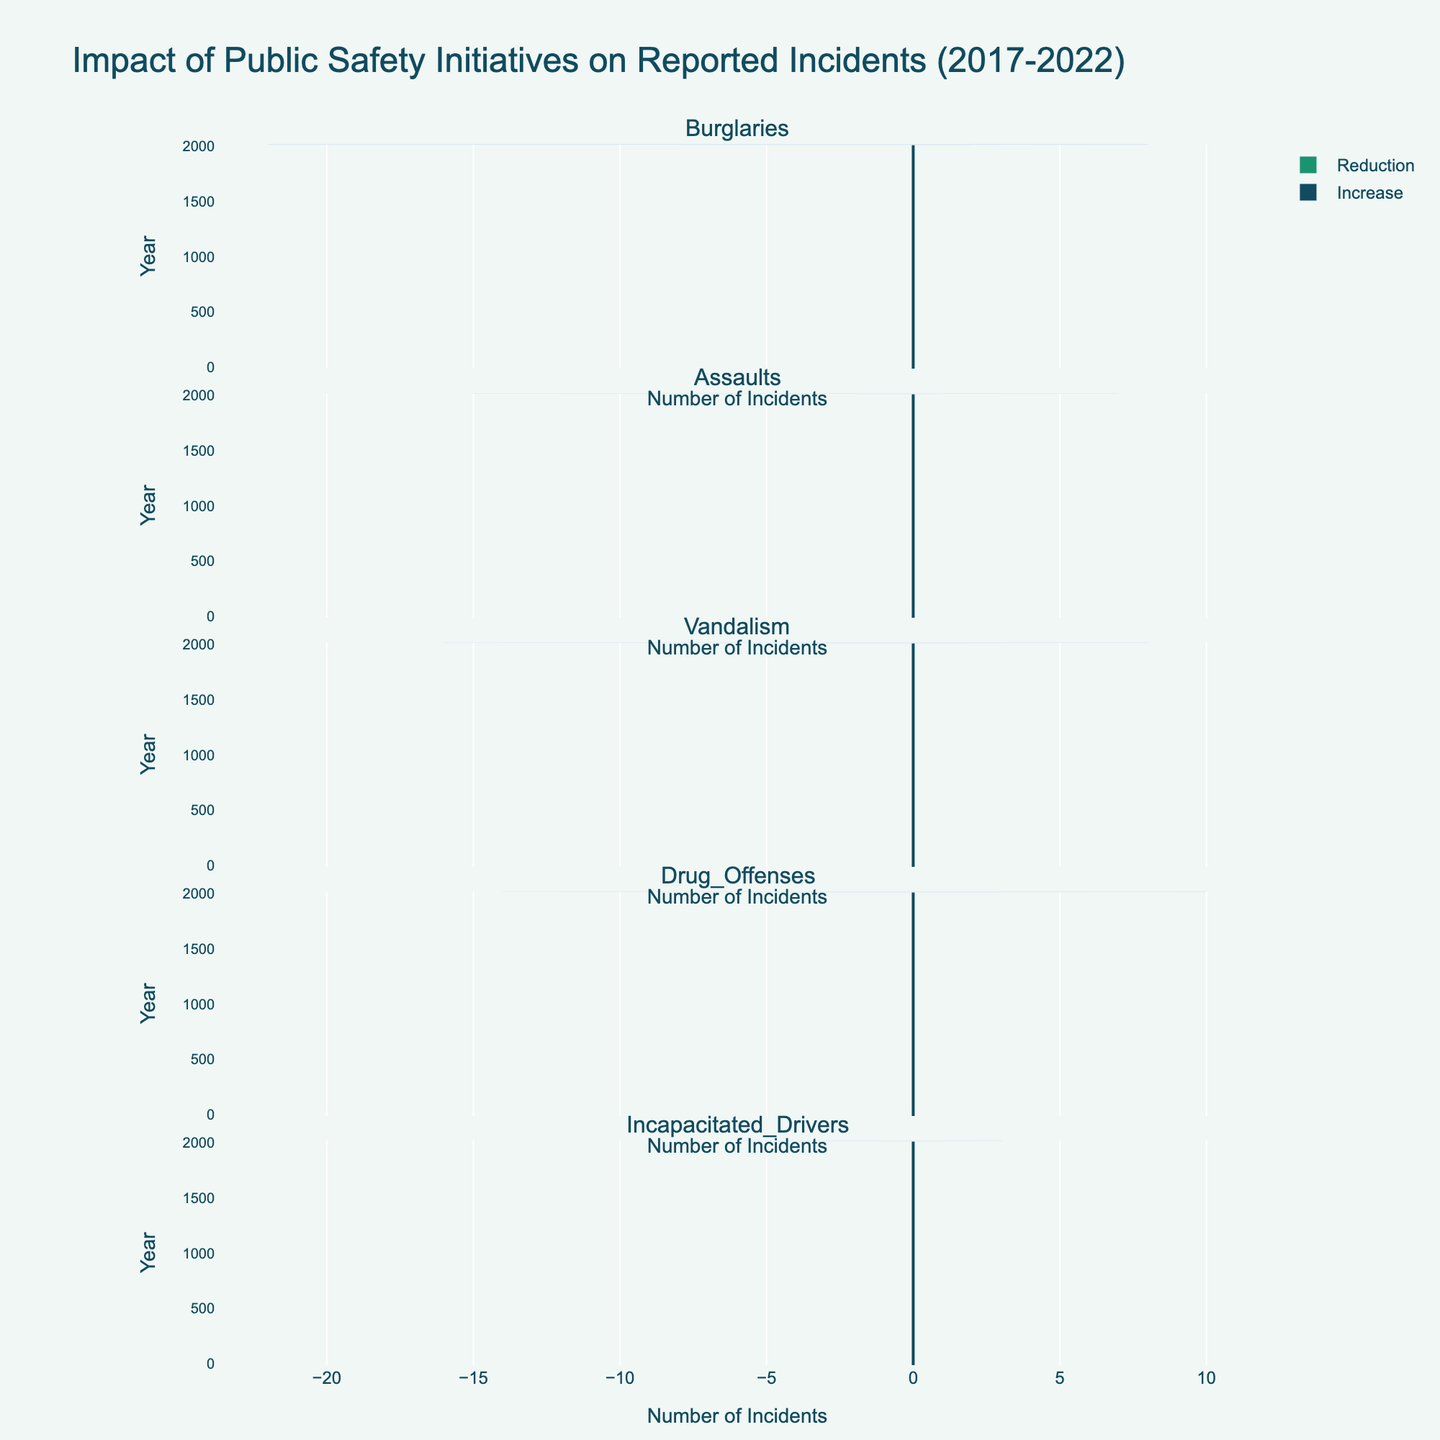What is the total increase in reported burglaries over the years 2017 to 2022? To find the total increase in burglaries, sum the increase values for burglaries from 2017 to 2022: 2 + 3 + 4 + 5 + 6 + 8. The total increase is 28.
Answer: 28 Which year experienced the highest reduction in burglaries? By observing the reduction bars for burglaries across the years, the year with the longest reduction bar is 2022 with a reduction value of 22.
Answer: 2022 What is the difference between the reduction and increase of reported assaults in 2022? First, locate the reduction and increase values for assaults in 2022. They are 15 and 7, respectively. Subtract the increase from the reduction: 15 - 7 = 8.
Answer: 8 Which incident type saw the most significant reduction in incidents in 2020? Compare the length of the reduction bars for all incident types in 2020. Vandalism has the longest reduction bar with a value of 9.
Answer: Vandalism How many more incidents were reduced than increased for incapacitated drivers in 2019? For 2019, incapacitated drivers had a reduction of 3 and an increase of 2. Subtract the increase from the reduction: 3 - 2 = 1.
Answer: 1 Between 2017 and 2022, which incident type consistently shows an increase and reduction every year? Each incident type shows both an increase and reduction every year. Reviewing the chart, existing bars for each category confirm this.
Answer: All What is the average annual increase in drug offenses from 2017 to 2022? Sum the increase values for drug offenses across the years: 3 + 5 + 6 + 8 + 10 + 9 = 41. Then divide by the number of years: 41 / 6 ≈ 6.83.
Answer: 6.83 How does the reduction in vandalism in 2022 compare to that in 2021? Vandalism reduction in 2022 is 16, and in 2021, it is 14. So, the reduction in 2022 is 2 more than in 2021.
Answer: 2 more Which incident type had the smallest increase in incidents in 2017? Incapacitated drivers had the smallest increase in 2017 with a value of 1.
Answer: Incapacitated drivers 